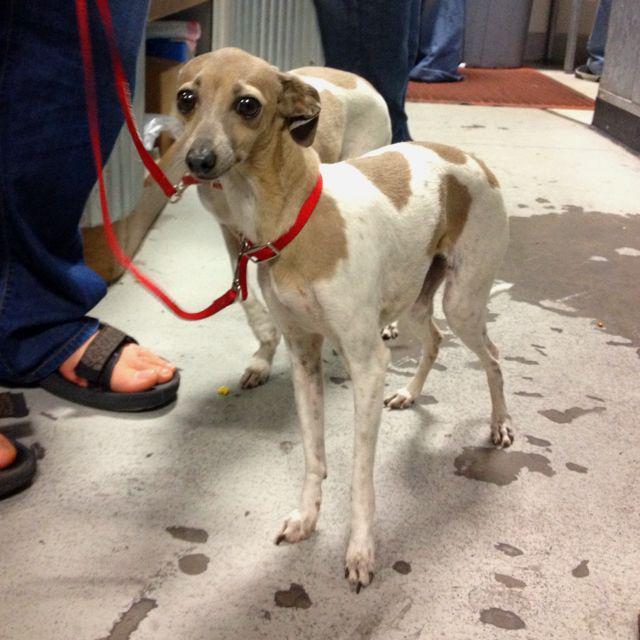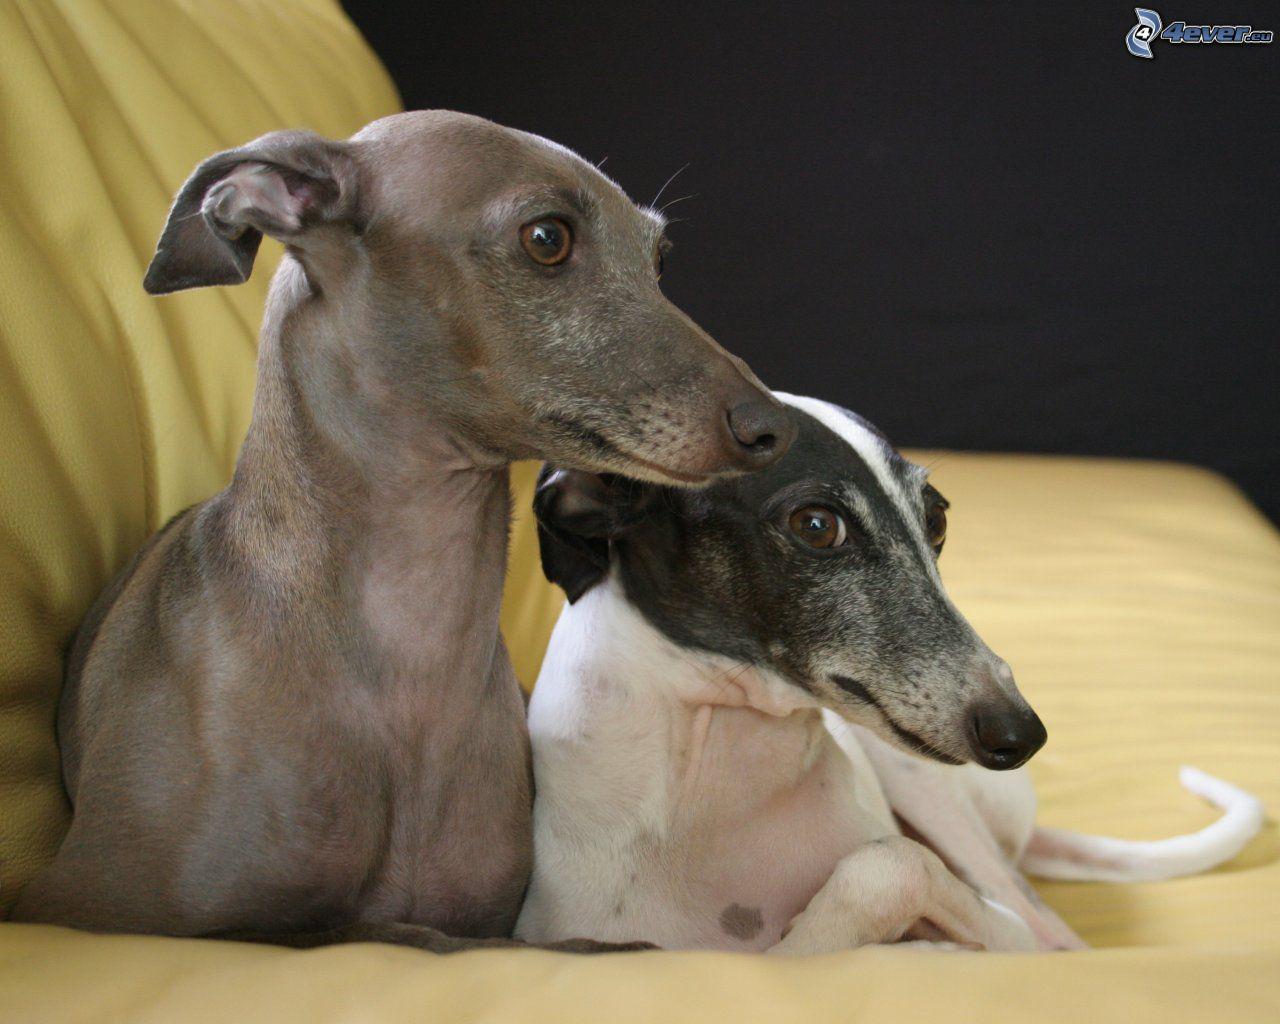The first image is the image on the left, the second image is the image on the right. Considering the images on both sides, is "The dogs in the image on the right are standing on a tiled floor." valid? Answer yes or no. No. The first image is the image on the left, the second image is the image on the right. For the images shown, is this caption "Two hounds of different colors are side-by-side on a soft surface, and at least one dog is reclining." true? Answer yes or no. Yes. 